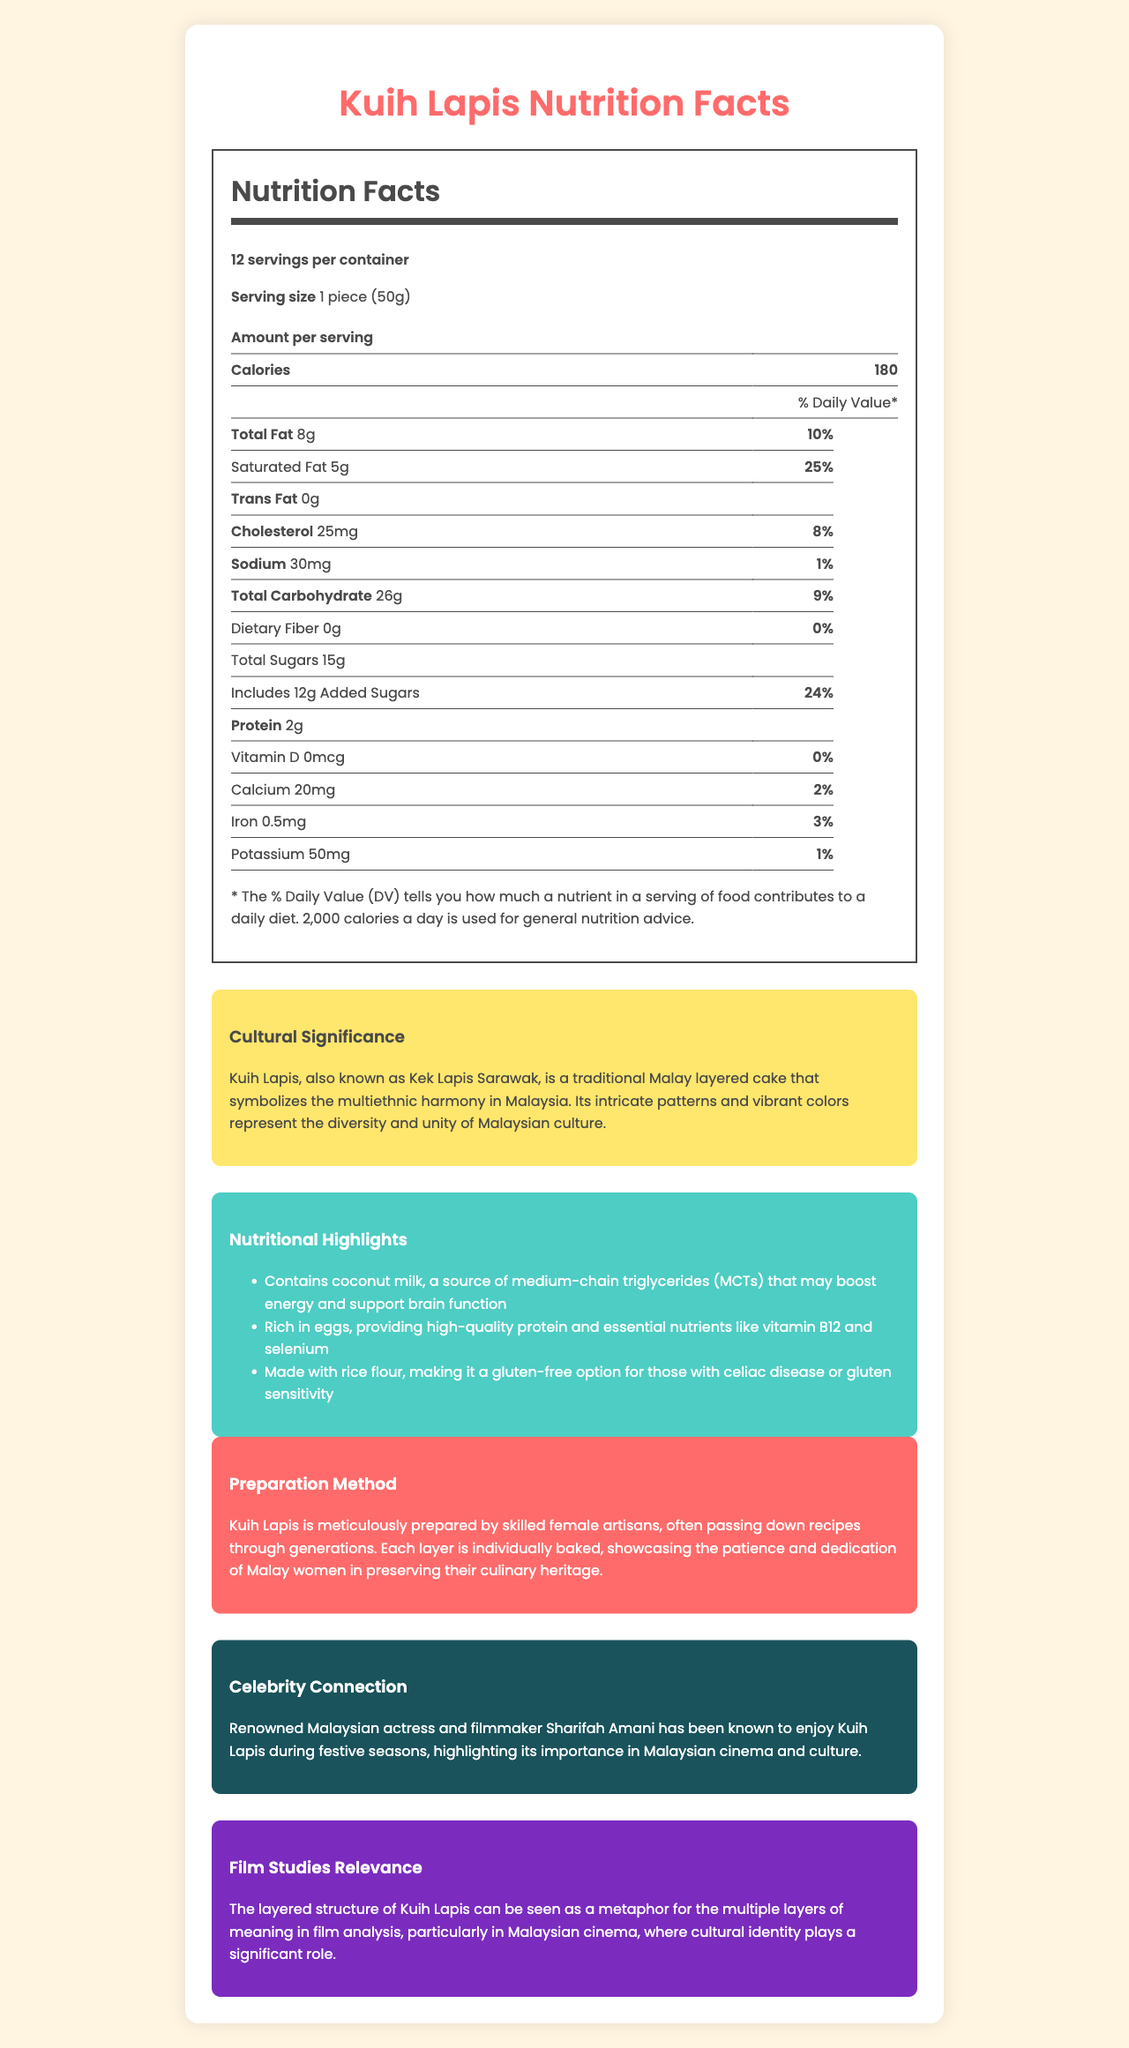what is the serving size of Kuih Lapis? The document specifies that the serving size is 1 piece weighing 50 grams.
Answer: 1 piece (50g) how many pieces are there in one container? The document states that there are 12 servings per container, implying 12 pieces of Kuih Lapis in total.
Answer: 12 how many calories are in one piece of Kuih Lapis? The document indicates that each serving, which is one piece, contains 180 calories.
Answer: 180 calories what is the percentage of daily value for saturated fat in one piece? The document shows that one piece contains 5g of saturated fat, which amounts to 25% of the daily value.
Answer: 25% how much protein does one piece of Kuih Lapis contain? The document lists the protein content as 2g per serving.
Answer: 2g what is the total carbohydrate content in one piece? The document states that each piece has 26g of total carbohydrates.
Answer: 26g which ingredient in Kuih Lapis aids in making it gluten-free? The document highlights that Kuih Lapis is made with rice flour, making it a gluten-free option.
Answer: Rice flour who is a famous person known to enjoy Kuih Lapis? The document mentions that Sharifah Amani, a renowned Malaysian actress and filmmaker, enjoys Kuih Lapis during festive seasons.
Answer: Sharifah Amani which of the following is NOT true about Kuih Lapis? A. It is gluten-free B. It contains high-quality protein from eggs C. It has 100mg of cholesterol The document points out that Kuih Lapis is gluten-free (A) and contains high-quality protein from eggs (B). However, it contains 25mg of cholesterol, not 100mg (C).
Answer: C what is the main metaphorical significance of Kuih Lapis in film studies? A. Represents the climax of a film B. Reflects the multiple layers of meaning in film analysis C. Symbolizes the resolution of a storyline D. Portrays the setting of a film The document explains that the layered structure of Kuih Lapis represents the multiple layers of meaning in film analysis.
Answer: B is Kuih Lapis a good source of dietary fiber? The document lists the dietary fiber content as 0g per serving, meaning it is not a source of dietary fiber.
Answer: No summarize the main cultural and nutritional significance of Kuih Lapis. The document highlights the cultural symbolism of Kuih Lapis in representing multiethnic harmony through its layered and vibrant patterns. Nutritionally, it features benefits such as medium-chain triglycerides from coconut milk, quality protein from eggs, and is gluten-free. The preparation method emphasizes the meticulous effort by female artisans.
Answer: Kuih Lapis, a traditional Malay layered cake, symbolizes Malaysia's multiethnic harmony. It contains medium-chain triglycerides from coconut milk for energy, high-quality protein and nutrients from eggs, and is gluten-free due to rice flour. It also represents the dedication of skilled female artisans. how many daily value percentages are given for vitamins and minerals? The document lists daily value percentages for Vitamin D, Calcium, Iron, and Potassium.
Answer: Four what does the presence of added sugars in Kuih Lapis imply about its overall healthiness? The document notes that each piece includes 12g of added sugars, which implies it could be higher in sugar and less suitable for those monitoring sugar intake.
Answer: It may have a higher sugar content. what inspired the layered structure in Kuih Lapis? The document states that the intricate patterns and vibrant colors of Kuih Lapis symbolize Malaysia's diversity and unity.
Answer: The multiethnic harmony and diversity in Malaysian culture who typically prepares Kuih Lapis, and what does it signify about their role? The document details that Kuih Lapis is prepared by skilled female artisans, showcasing patience, dedication, and the preservation of culinary heritage passed down through generations.
Answer: Skilled female artisans how does Kuih Lapis fare in sodium content compared to daily value percentages? The document lists the sodium content as 30mg, accounting for only 1% of the daily value, indicating low sodium content.
Answer: It has a low sodium content of 1% daily value. when was Kuih Lapis first created? The document does not provide any details regarding the creation date or historical timeline of Kuih Lapis.
Answer: Not enough information 